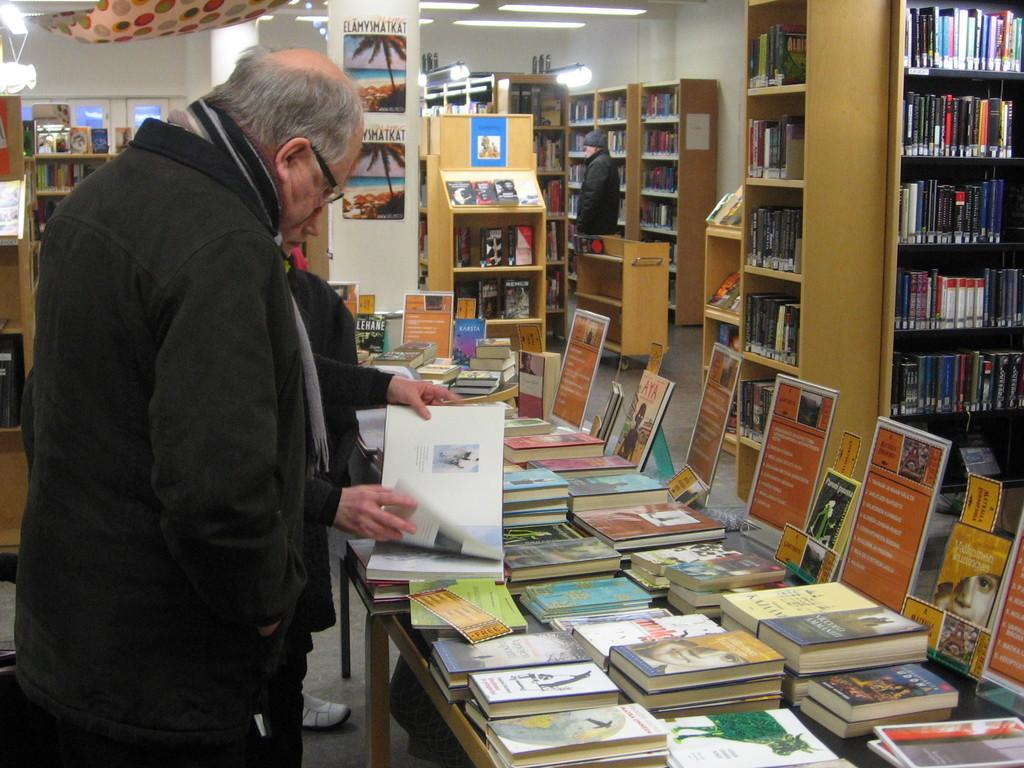How many people are in the image? There are two persons in the image. What are the two persons doing in the image? The two persons are standing in front of a table. What is on the table in the image? The table has many books on it. What can be seen around the persons in the image? There are many bookshelves around the persons. What type of veil is draped over the bookshelf in the image? There is no veil present in the image; it features two persons standing in front of a table with many books and bookshelves. Is the sweater worn by one of the persons in the image? The provided facts do not mention any clothing worn by the persons, so we cannot determine if a sweater is present. 